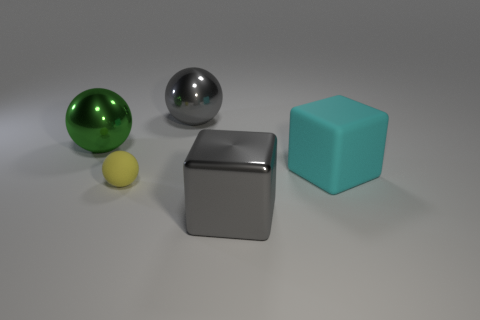What material is the gray cube that is the same size as the green metallic thing?
Offer a very short reply. Metal. Is there a green metal thing of the same size as the green metal ball?
Provide a short and direct response. No. The metal block has what color?
Your answer should be very brief. Gray. There is a metal thing that is right of the shiny ball that is on the right side of the tiny matte ball; what is its color?
Offer a very short reply. Gray. There is a big metallic object behind the metal object left of the matte object that is left of the gray shiny ball; what is its shape?
Your answer should be compact. Sphere. What number of other large things have the same material as the yellow object?
Keep it short and to the point. 1. There is a sphere right of the yellow rubber sphere; what number of matte balls are behind it?
Your response must be concise. 0. What number of large purple matte objects are there?
Keep it short and to the point. 0. Are the yellow thing and the gray object that is behind the big cyan block made of the same material?
Provide a succinct answer. No. Do the cube that is in front of the rubber sphere and the tiny sphere have the same color?
Your response must be concise. No. 